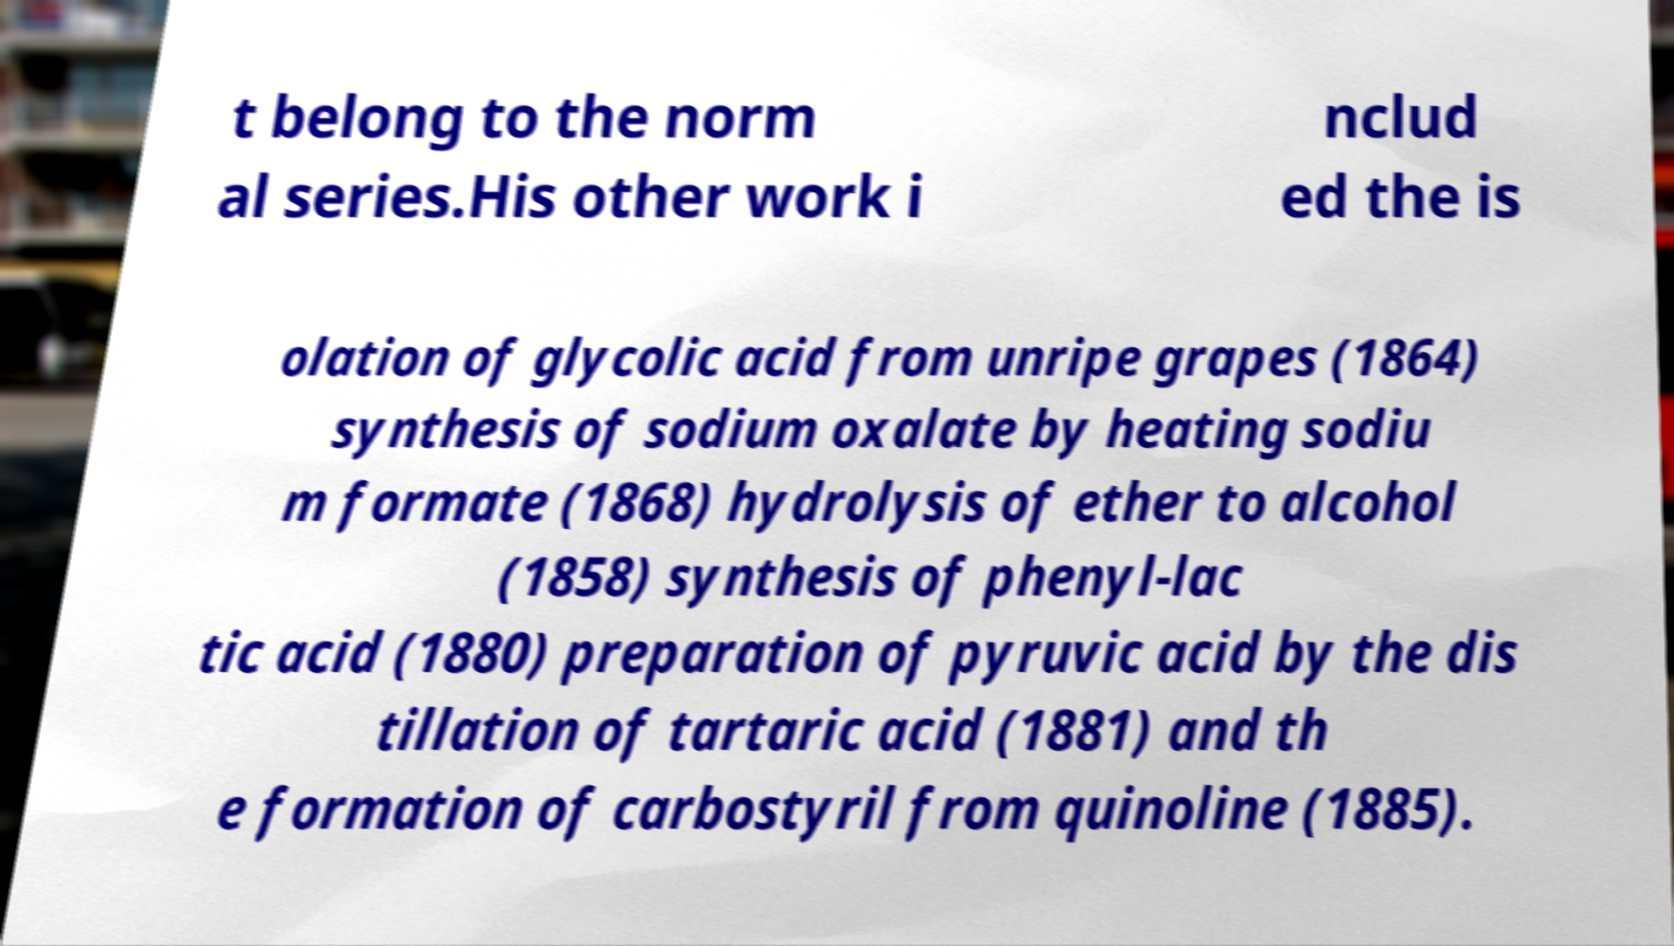What messages or text are displayed in this image? I need them in a readable, typed format. t belong to the norm al series.His other work i nclud ed the is olation of glycolic acid from unripe grapes (1864) synthesis of sodium oxalate by heating sodiu m formate (1868) hydrolysis of ether to alcohol (1858) synthesis of phenyl-lac tic acid (1880) preparation of pyruvic acid by the dis tillation of tartaric acid (1881) and th e formation of carbostyril from quinoline (1885). 